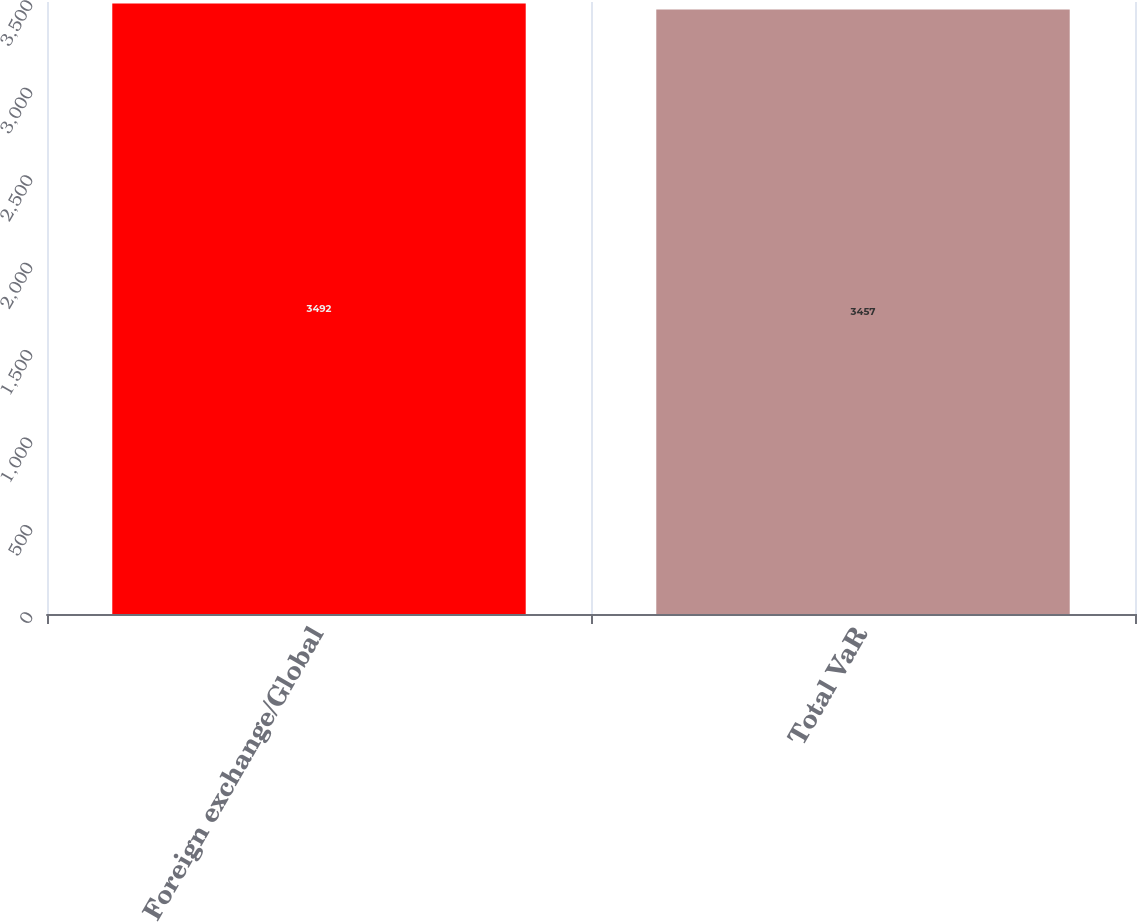<chart> <loc_0><loc_0><loc_500><loc_500><bar_chart><fcel>Foreign exchange/Global<fcel>Total VaR<nl><fcel>3492<fcel>3457<nl></chart> 